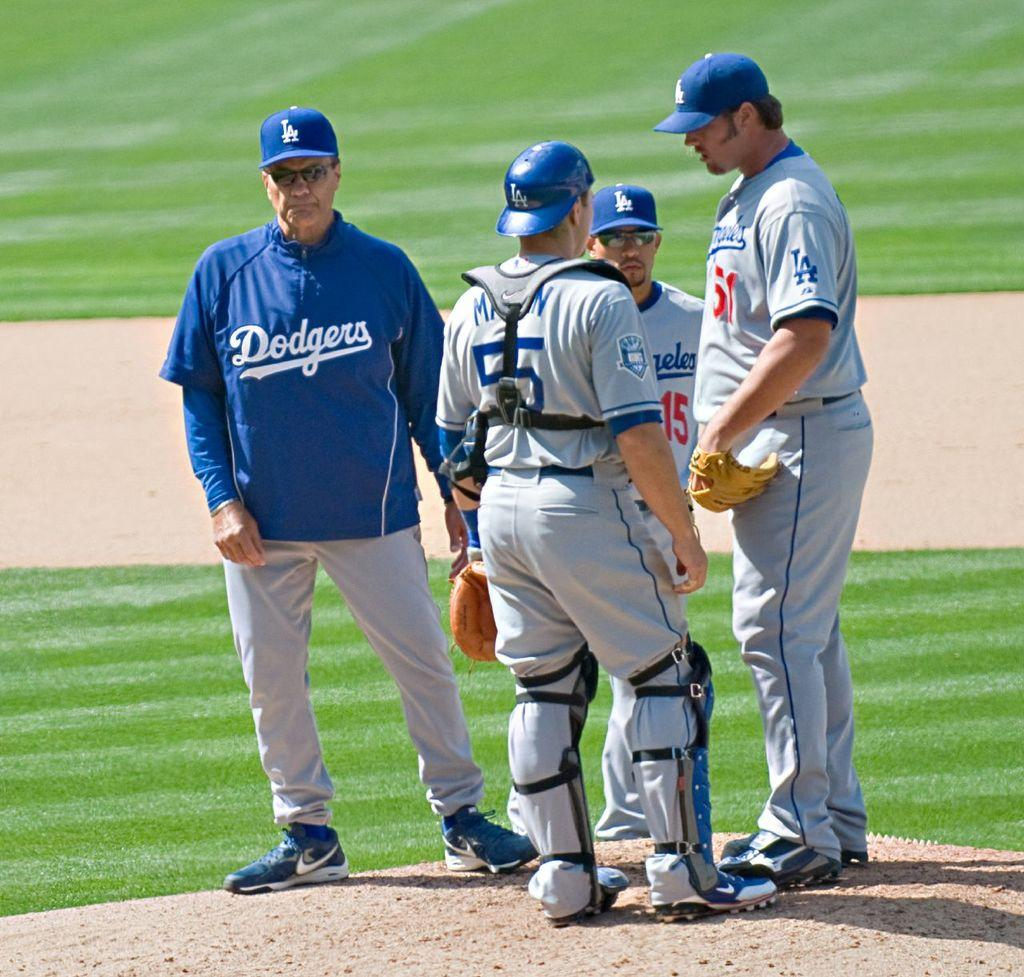<image>
Relay a brief, clear account of the picture shown. Dodgers team players talking together on the field 